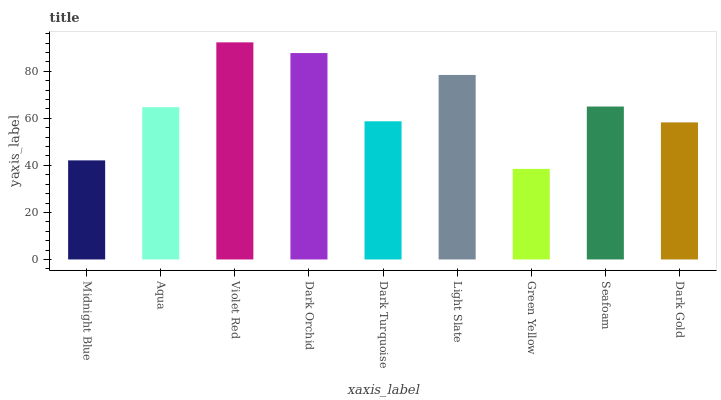Is Green Yellow the minimum?
Answer yes or no. Yes. Is Violet Red the maximum?
Answer yes or no. Yes. Is Aqua the minimum?
Answer yes or no. No. Is Aqua the maximum?
Answer yes or no. No. Is Aqua greater than Midnight Blue?
Answer yes or no. Yes. Is Midnight Blue less than Aqua?
Answer yes or no. Yes. Is Midnight Blue greater than Aqua?
Answer yes or no. No. Is Aqua less than Midnight Blue?
Answer yes or no. No. Is Aqua the high median?
Answer yes or no. Yes. Is Aqua the low median?
Answer yes or no. Yes. Is Midnight Blue the high median?
Answer yes or no. No. Is Light Slate the low median?
Answer yes or no. No. 